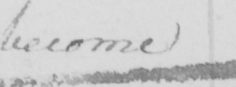What is written in this line of handwriting? become 